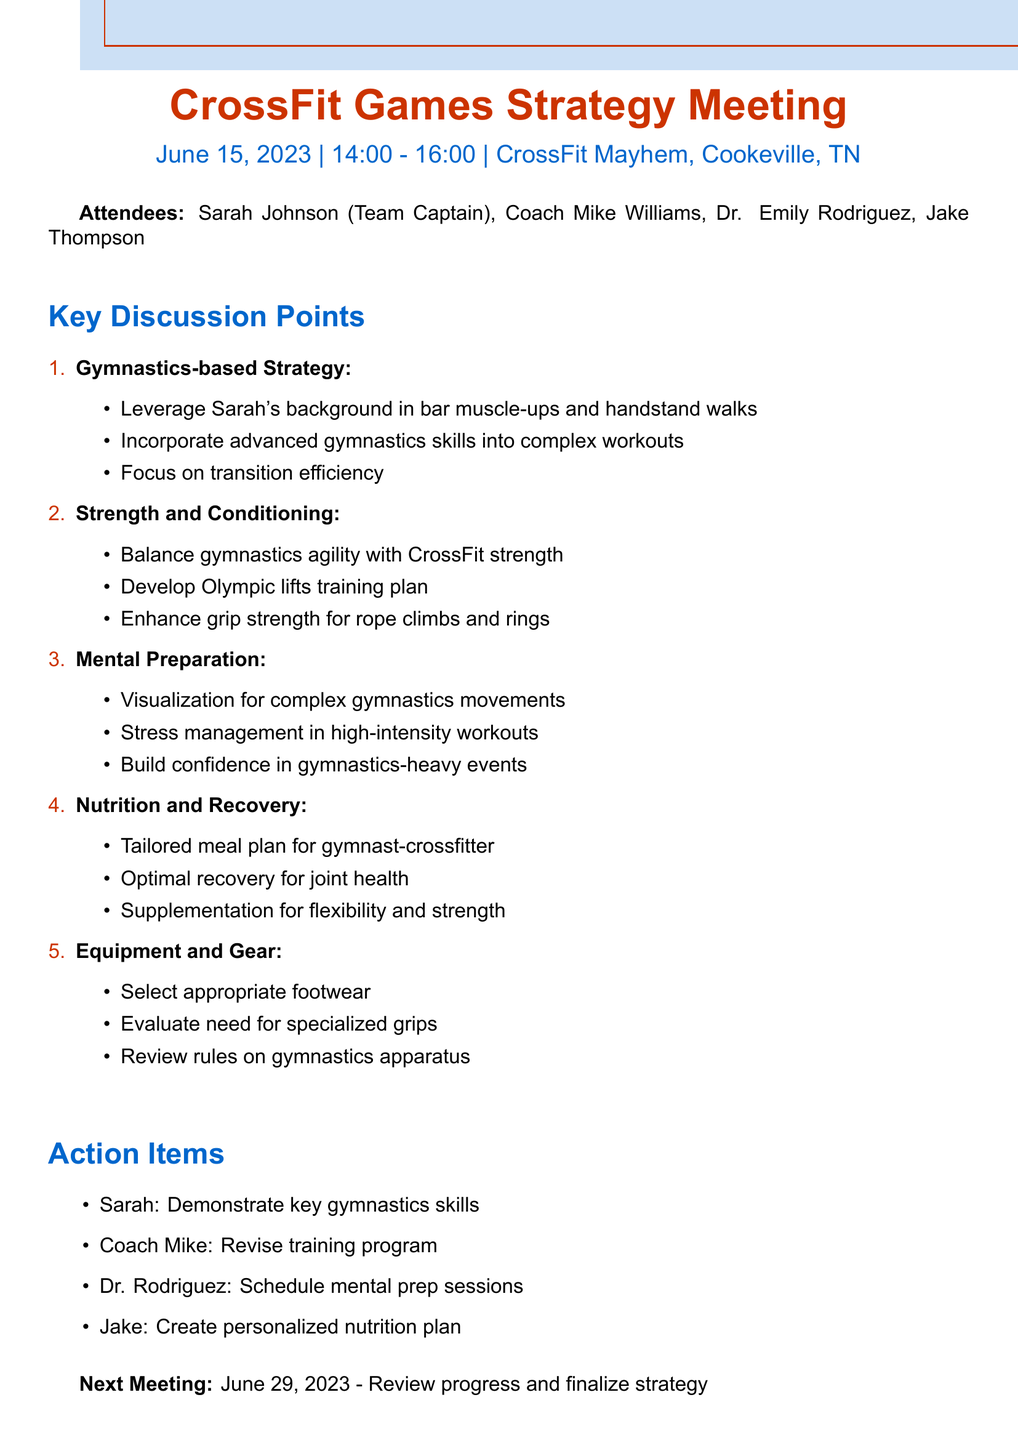What is the date of the meeting? The date of the meeting is clearly stated in the document.
Answer: June 15, 2023 Who is the team captain? The document lists the attendees, including their roles.
Answer: Sarah Johnson What was one focus of the gymnastics-based strategy? The agenda items specify points under each focus area, including gymnastics strategies.
Answer: Leverage Sarah's gymnastics background in bar muscle-ups and handstand walks What is one action item for Dr. Rodriguez? Action items are distinctly listed in the document by person responsible.
Answer: Schedule mental prep sessions How long is the next meeting scheduled for? The next meeting date is mentioned with a focus on reviewing progress, allowing for calculation of time duration.
Answer: 2023-06-29 Which specialist is responsible for nutrition? The attendees include various specialists, with specific roles mentioned.
Answer: Jake Thompson What type of technique is suggested for mental preparation? The mental preparation discussion provides specific techniques to be integrated into practice.
Answer: Visualization techniques for complex gymnastics movements What is the meeting location? The document specifically lists the location of the meeting.
Answer: CrossFit Mayhem, Cookeville, TN What is emphasized for grip strength in the strength and conditioning section? The strength and conditioning points elaborate on necessary skills related to grip strength.
Answer: Rope climbs and ring work 